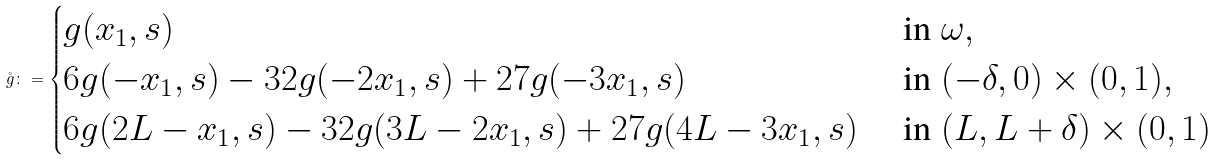Convert formula to latex. <formula><loc_0><loc_0><loc_500><loc_500>\mathring { g } \colon = \begin{cases} { g } ( x _ { 1 } , s ) & \text { in } \omega , \\ 6 { g } ( - x _ { 1 } , s ) - 3 2 { g } ( - 2 x _ { 1 } , s ) + 2 7 g ( - 3 x _ { 1 } , s ) & \text { in } ( - \delta , 0 ) \times ( 0 , 1 ) , \\ 6 { g } ( 2 L - x _ { 1 } , s ) - 3 2 { g } ( 3 L - 2 x _ { 1 } , s ) + 2 7 g ( 4 L - 3 x _ { 1 } , s ) & \text { in } ( L , L + \delta ) \times ( 0 , 1 ) \end{cases}</formula> 